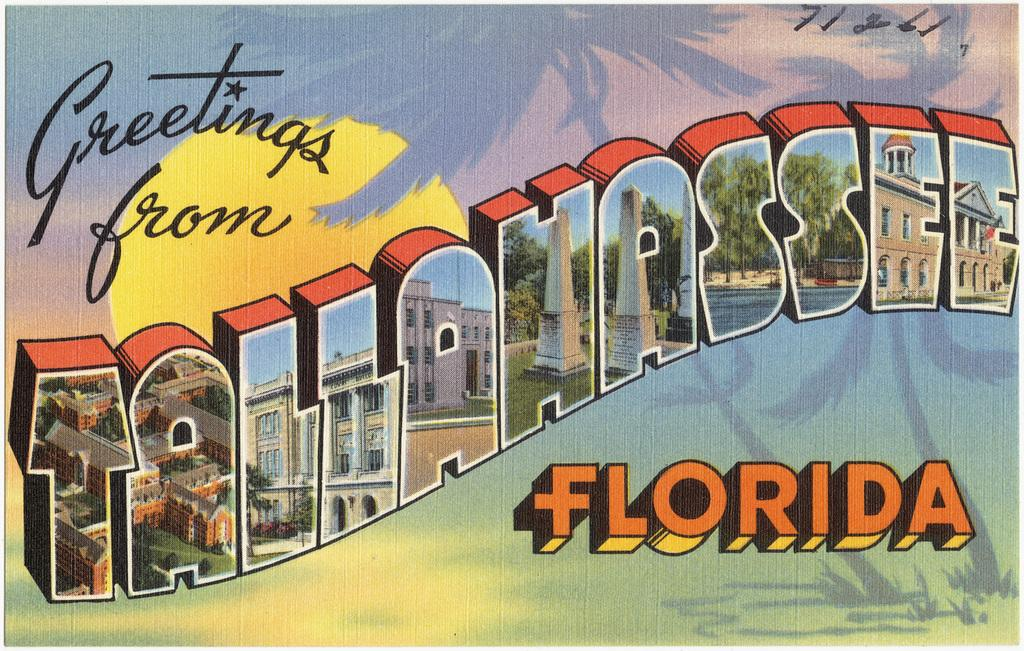Provide a one-sentence caption for the provided image. A postcard from Tallahassee Florida with lots of colorful imagery. 